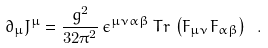Convert formula to latex. <formula><loc_0><loc_0><loc_500><loc_500>\partial _ { \mu } J ^ { \mu } = \frac { g ^ { 2 } } { 3 2 \pi ^ { 2 } } \, \epsilon ^ { \mu \nu \alpha \beta } \, T r \, \left ( F _ { \mu \nu } F _ { \alpha \beta } \right ) \ .</formula> 